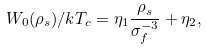<formula> <loc_0><loc_0><loc_500><loc_500>W _ { 0 } ( \rho _ { s } ) / k T _ { c } = \eta _ { 1 } \frac { \rho _ { s } } { \sigma _ { f } ^ { - 3 } } + \eta _ { 2 } ,</formula> 